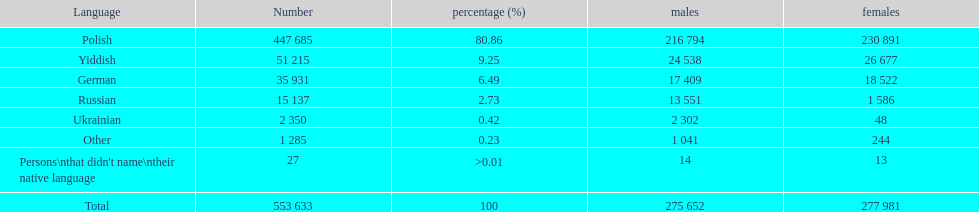What is the least used language in terms of speakers? Ukrainian. 